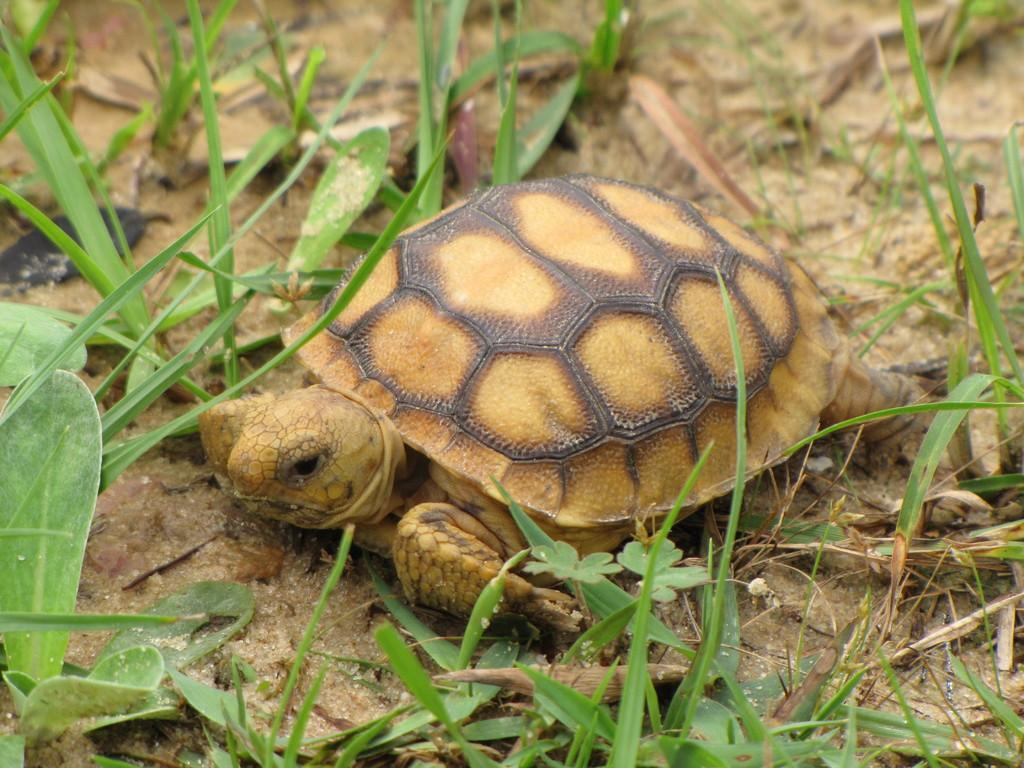What type of animal is in the image? There is a turtle in the image. What type of vegetation is present in the image? There is grass in the image. Where is the aunt sitting in the image? There is no aunt present in the image; it only features a turtle and grass. 